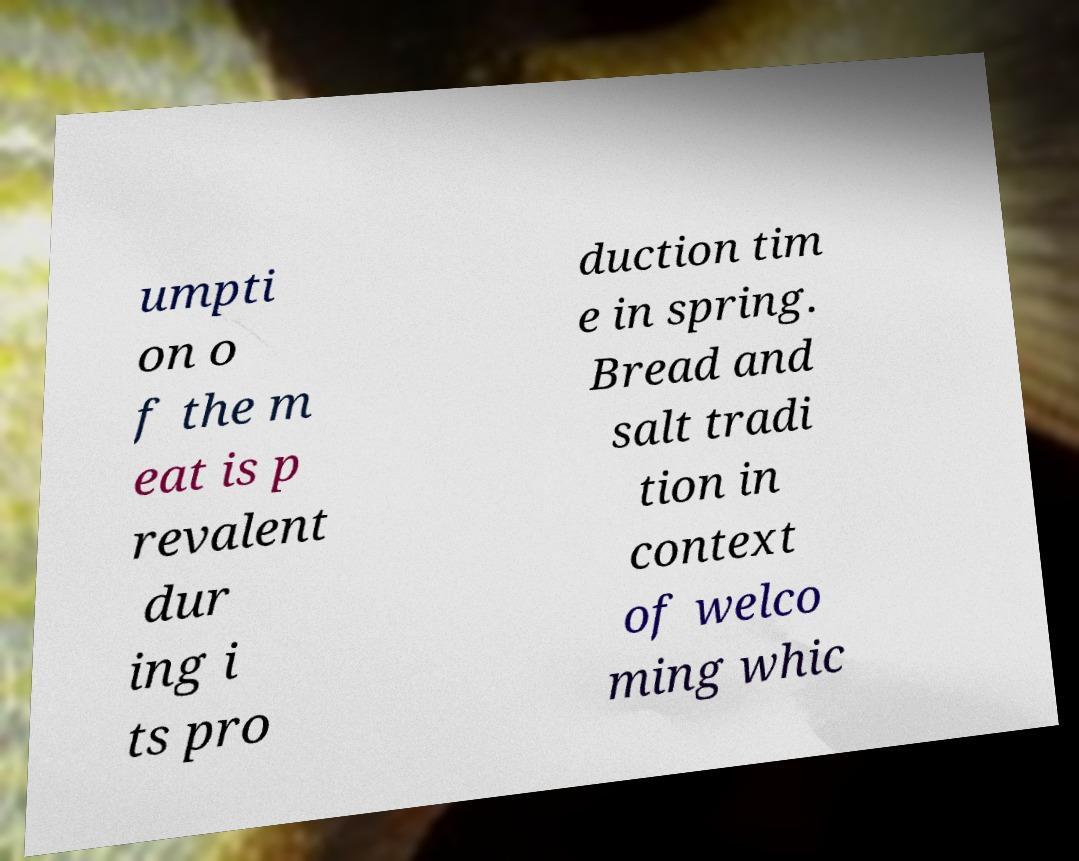Please read and relay the text visible in this image. What does it say? umpti on o f the m eat is p revalent dur ing i ts pro duction tim e in spring. Bread and salt tradi tion in context of welco ming whic 